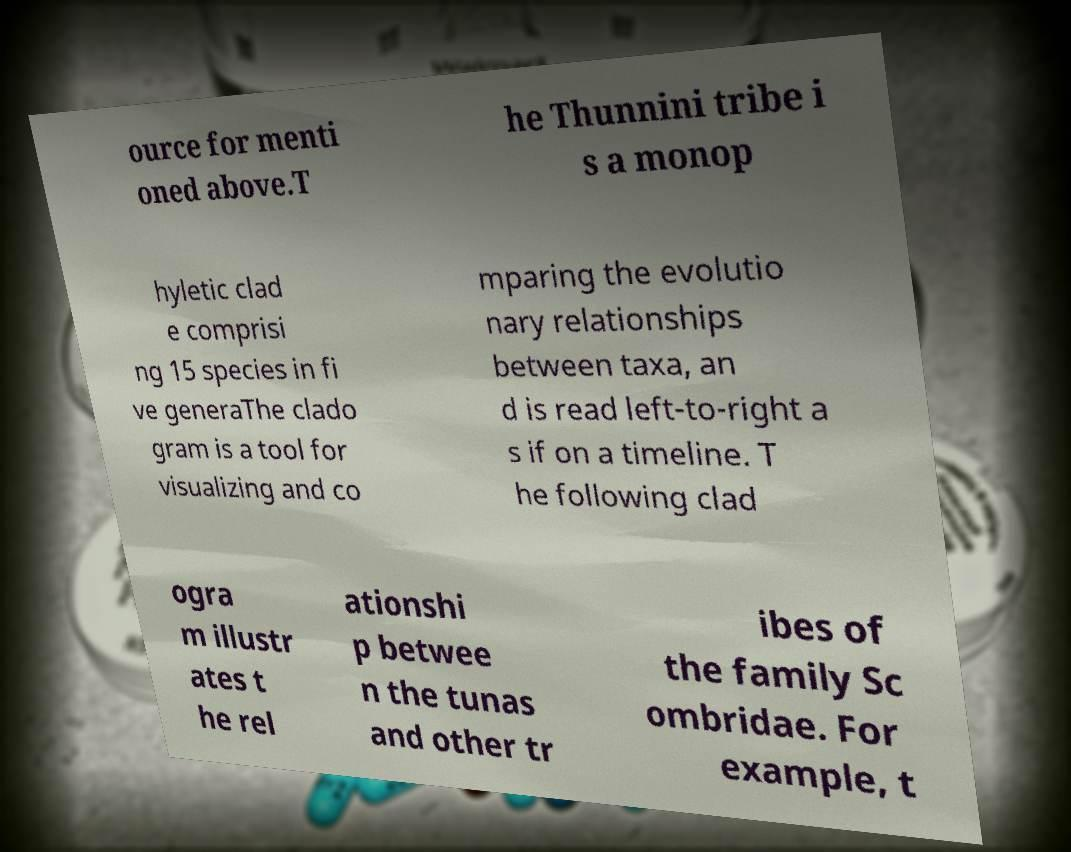Can you accurately transcribe the text from the provided image for me? ource for menti oned above.T he Thunnini tribe i s a monop hyletic clad e comprisi ng 15 species in fi ve generaThe clado gram is a tool for visualizing and co mparing the evolutio nary relationships between taxa, an d is read left-to-right a s if on a timeline. T he following clad ogra m illustr ates t he rel ationshi p betwee n the tunas and other tr ibes of the family Sc ombridae. For example, t 